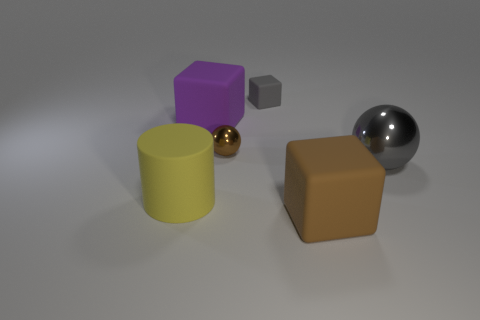Subtract all brown cubes. How many cubes are left? 2 Subtract all purple cubes. How many cubes are left? 2 Subtract all balls. How many objects are left? 4 Add 2 brown shiny objects. How many brown shiny objects are left? 3 Add 1 tiny gray things. How many tiny gray things exist? 2 Add 1 purple cubes. How many objects exist? 7 Subtract 1 gray spheres. How many objects are left? 5 Subtract 1 cylinders. How many cylinders are left? 0 Subtract all red blocks. Subtract all red balls. How many blocks are left? 3 Subtract all red cylinders. How many gray spheres are left? 1 